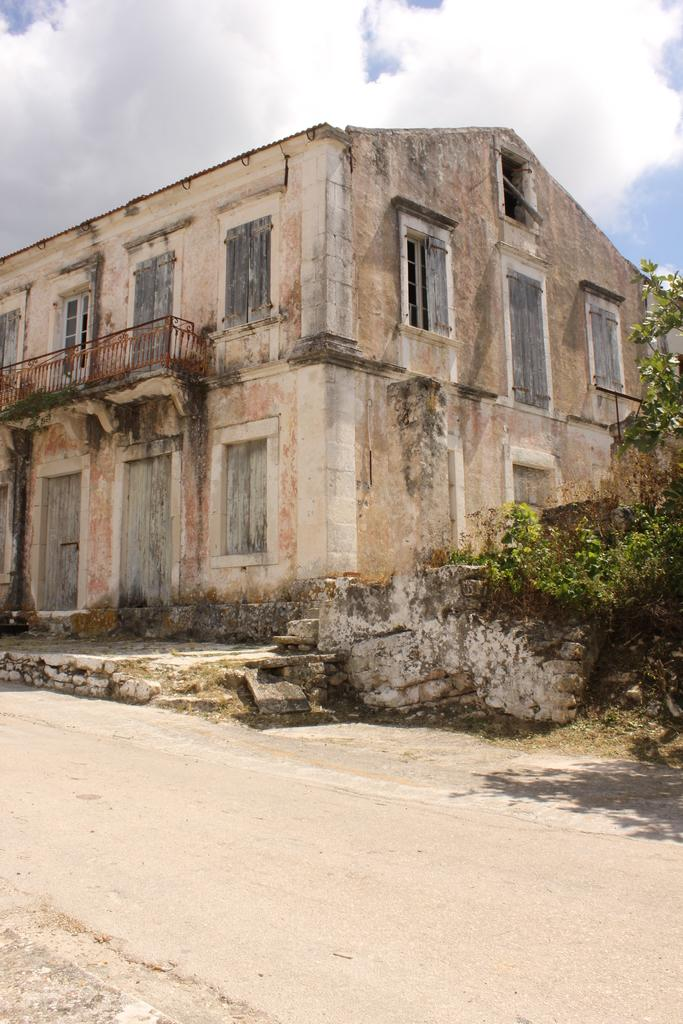What type of structure is located in the middle of the image? There is an old building in the middle of the image. What is visible at the top of the image? The sky is visible at the top of the image. What is at the bottom of the image? There is a road at the bottom of the image. What type of vegetation is on the right side of the image? There is a tree on the right side of the image. Where is the gold nest located in the image? There is no gold nest present in the image. Is there a lawyer standing next to the tree in the image? There is no lawyer present in the image. 